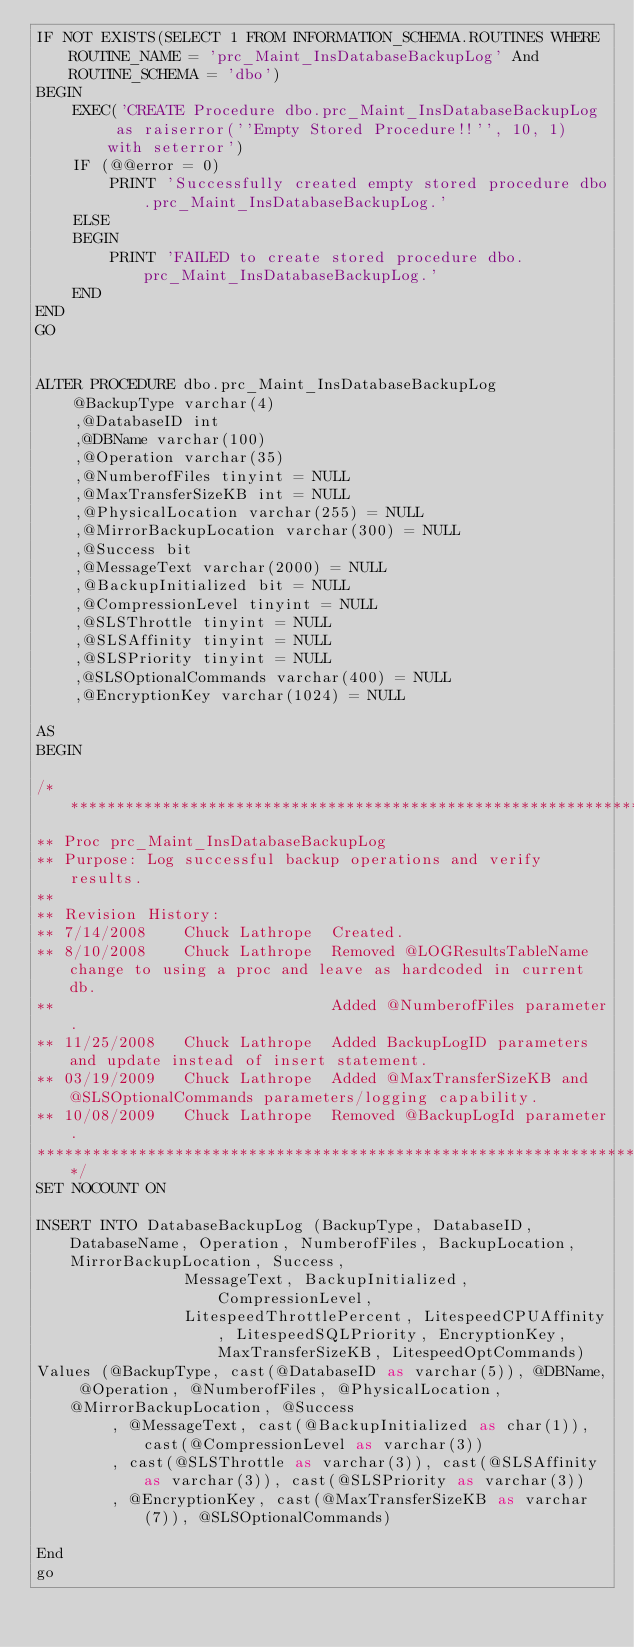Convert code to text. <code><loc_0><loc_0><loc_500><loc_500><_SQL_>IF NOT EXISTS(SELECT 1 FROM INFORMATION_SCHEMA.ROUTINES WHERE ROUTINE_NAME = 'prc_Maint_InsDatabaseBackupLog' And ROUTINE_SCHEMA = 'dbo')
BEGIN
	EXEC('CREATE Procedure dbo.prc_Maint_InsDatabaseBackupLog  as raiserror(''Empty Stored Procedure!!'', 10, 1) with seterror')
	IF (@@error = 0)
		PRINT 'Successfully created empty stored procedure dbo.prc_Maint_InsDatabaseBackupLog.'
	ELSE
	BEGIN
		PRINT 'FAILED to create stored procedure dbo.prc_Maint_InsDatabaseBackupLog.'
	END
END
GO


ALTER PROCEDURE dbo.prc_Maint_InsDatabaseBackupLog
	@BackupType varchar(4)
	,@DatabaseID int
	,@DBName varchar(100)
	,@Operation varchar(35)
	,@NumberofFiles tinyint = NULL
	,@MaxTransferSizeKB int = NULL
	,@PhysicalLocation varchar(255) = NULL
	,@MirrorBackupLocation varchar(300) = NULL
	,@Success bit
	,@MessageText varchar(2000) = NULL
	,@BackupInitialized bit = NULL
	,@CompressionLevel tinyint = NULL
	,@SLSThrottle tinyint = NULL
	,@SLSAffinity tinyint = NULL
	,@SLSPriority tinyint = NULL
	,@SLSOptionalCommands varchar(400) = NULL
	,@EncryptionKey varchar(1024) = NULL

AS
BEGIN

/*************************************************************************
** Proc prc_Maint_InsDatabaseBackupLog
** Purpose: Log successful backup operations and verify results.
**
** Revision History:
** 7/14/2008	Chuck Lathrope	Created.
** 8/10/2008	Chuck Lathrope	Removed @LOGResultsTableName change to using a proc and leave as hardcoded in current db.
**								Added @NumberofFiles parameter.
** 11/25/2008	Chuck Lathrope  Added BackupLogID parameters and update instead of insert statement.
** 03/19/2009	Chuck Lathrope	Added @MaxTransferSizeKB and @SLSOptionalCommands parameters/logging capability.
** 10/08/2009	Chuck Lathrope	Removed @BackupLogId parameter.
*****************************************************************************************/
SET NOCOUNT ON

INSERT INTO DatabaseBackupLog (BackupType, DatabaseID, DatabaseName, Operation, NumberofFiles, BackupLocation, MirrorBackupLocation, Success, 
				MessageText, BackupInitialized, CompressionLevel, 
				LitespeedThrottlePercent, LitespeedCPUAffinity, LitespeedSQLPriority, EncryptionKey, MaxTransferSizeKB, LitespeedOptCommands)
Values (@BackupType, cast(@DatabaseID as varchar(5)), @DBName, @Operation, @NumberofFiles, @PhysicalLocation, @MirrorBackupLocation, @Success
		, @MessageText, cast(@BackupInitialized as char(1)), cast(@CompressionLevel as varchar(3))
		, cast(@SLSThrottle as varchar(3)), cast(@SLSAffinity as varchar(3)), cast(@SLSPriority as varchar(3))
		, @EncryptionKey, cast(@MaxTransferSizeKB as varchar(7)), @SLSOptionalCommands)

End
go

</code> 